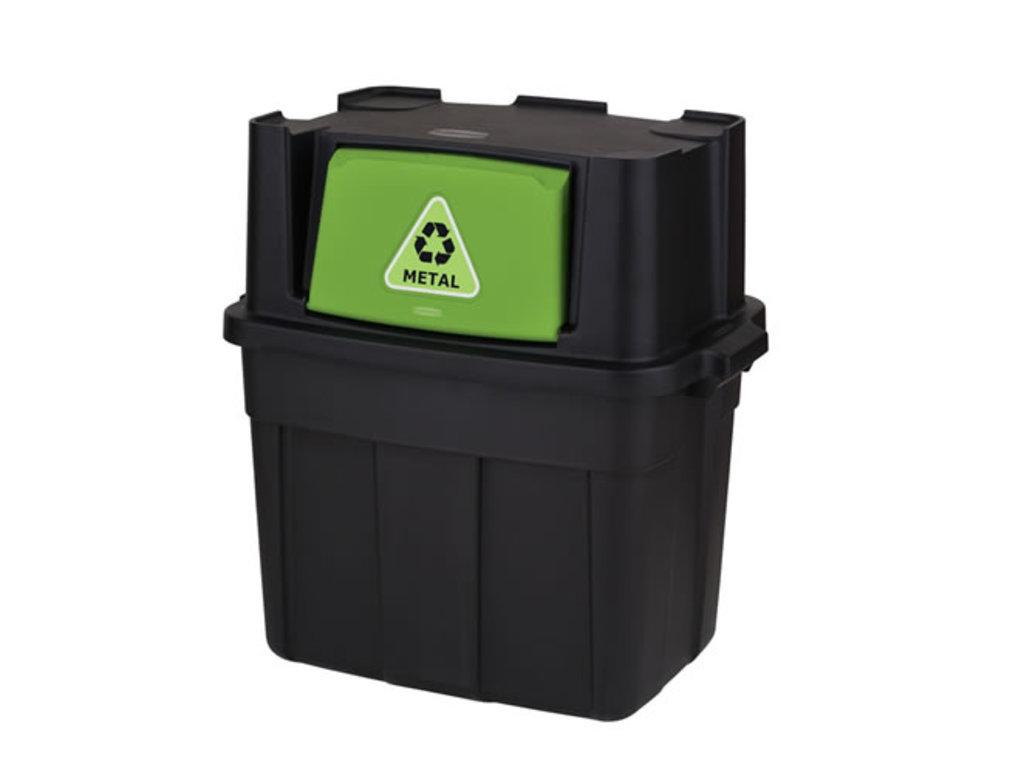Provide a one-sentence caption for the provided image. a black and green plastic container for recycling METAL. 